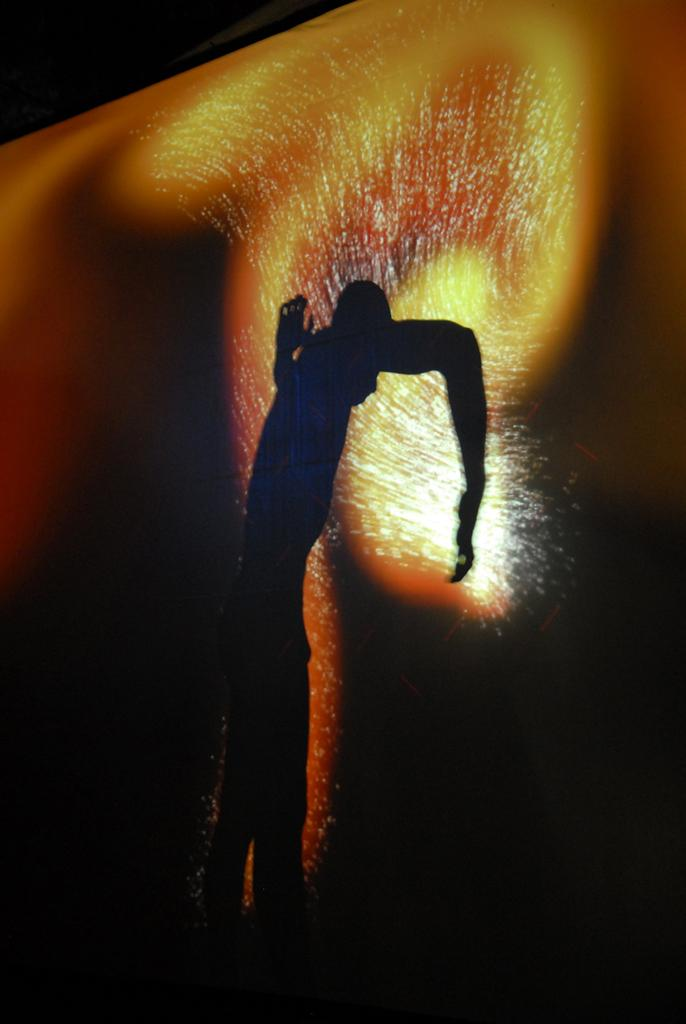What type of artwork is depicted in the image? The image is a painting. What can be seen in the painting besides the background? There is a shadow of a person in the painting. How would you describe the background of the painting? The background of the painting is dark in color. What type of key is being held by the person in the painting? There is no person or key present in the painting; only a shadow of a person can be seen. 